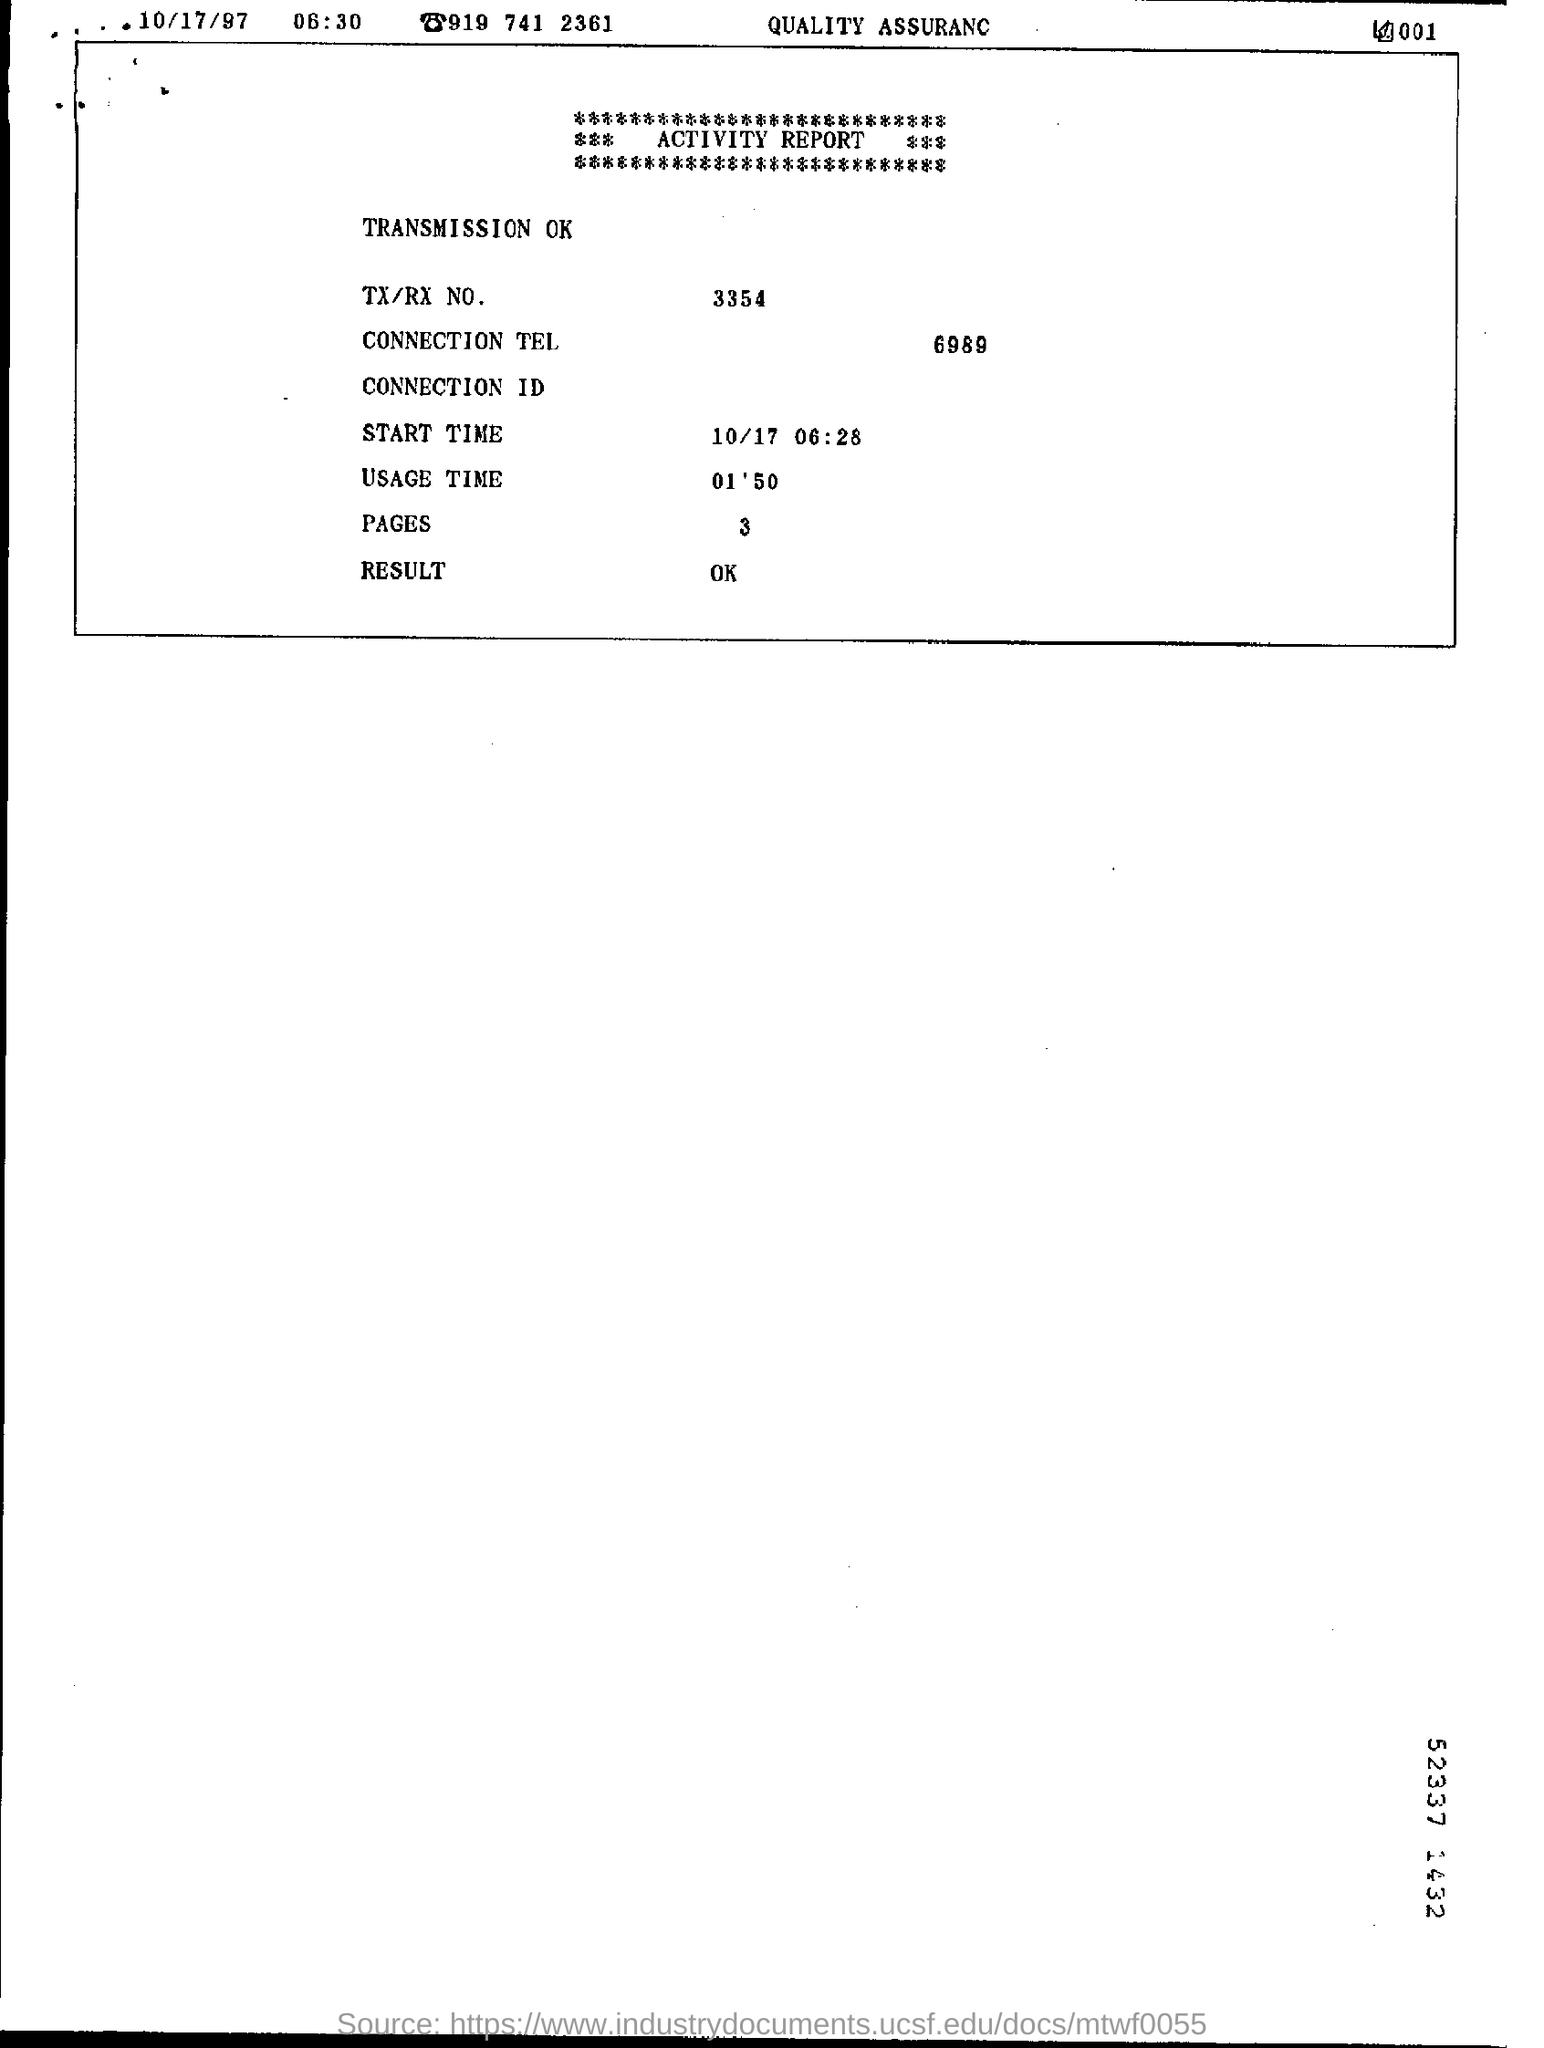What is the TX/RX No.?
Offer a terse response. 3354. What is the Connection Tel?
Make the answer very short. 6989. What is the Result?
Your answer should be very brief. Ok. 